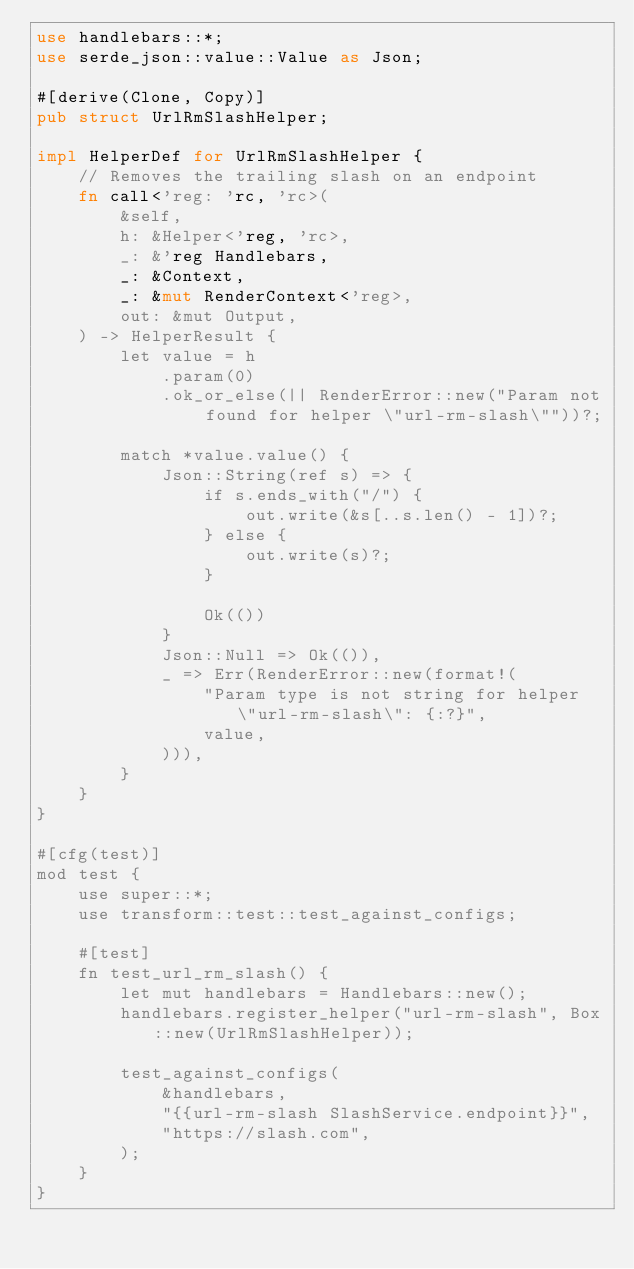<code> <loc_0><loc_0><loc_500><loc_500><_Rust_>use handlebars::*;
use serde_json::value::Value as Json;

#[derive(Clone, Copy)]
pub struct UrlRmSlashHelper;

impl HelperDef for UrlRmSlashHelper {
    // Removes the trailing slash on an endpoint
    fn call<'reg: 'rc, 'rc>(
        &self,
        h: &Helper<'reg, 'rc>,
        _: &'reg Handlebars,
        _: &Context,
        _: &mut RenderContext<'reg>,
        out: &mut Output,
    ) -> HelperResult {
        let value = h
            .param(0)
            .ok_or_else(|| RenderError::new("Param not found for helper \"url-rm-slash\""))?;

        match *value.value() {
            Json::String(ref s) => {
                if s.ends_with("/") {
                    out.write(&s[..s.len() - 1])?;
                } else {
                    out.write(s)?;
                }

                Ok(())
            }
            Json::Null => Ok(()),
            _ => Err(RenderError::new(format!(
                "Param type is not string for helper \"url-rm-slash\": {:?}",
                value,
            ))),
        }
    }
}

#[cfg(test)]
mod test {
    use super::*;
    use transform::test::test_against_configs;

    #[test]
    fn test_url_rm_slash() {
        let mut handlebars = Handlebars::new();
        handlebars.register_helper("url-rm-slash", Box::new(UrlRmSlashHelper));

        test_against_configs(
            &handlebars,
            "{{url-rm-slash SlashService.endpoint}}",
            "https://slash.com",
        );
    }
}
</code> 